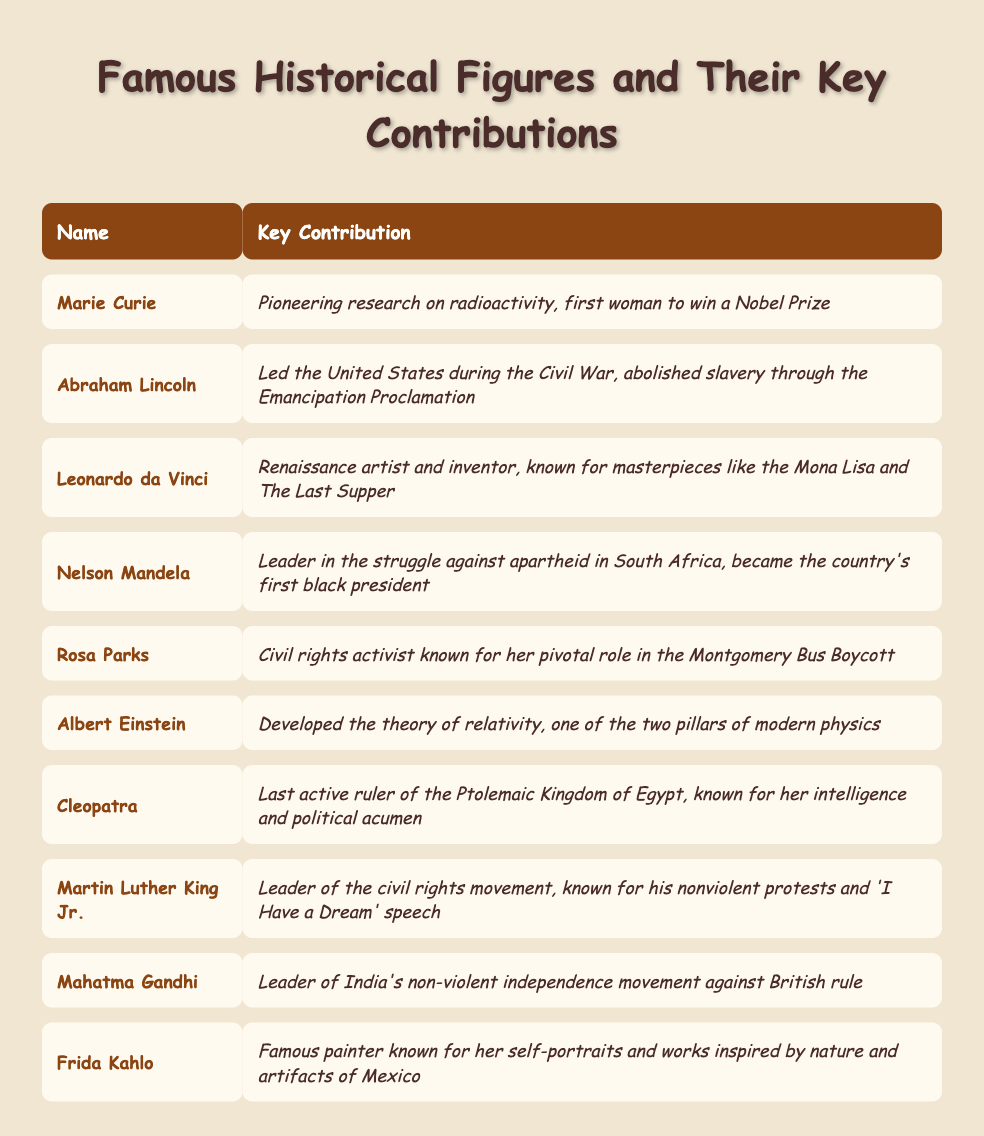What was Marie Curie's key contribution? Marie Curie's key contribution, as stated in the table, is pioneering research on radioactivity and being the first woman to win a Nobel Prize.
Answer: Pioneering research on radioactivity, first woman to win a Nobel Prize Who was the leader of the civil rights movement? The table indicates that Martin Luther King Jr. was the leader of the civil rights movement.
Answer: Martin Luther King Jr Which historical figure is known for the 'I Have a Dream' speech? Referring to the table, it shows that Martin Luther King Jr. is known for his 'I Have a Dream' speech.
Answer: Martin Luther King Jr Did Cleopatra rule Egypt? According to the table, it is true that Cleopatra was the last active ruler of the Ptolemaic Kingdom of Egypt.
Answer: Yes How many contributions focused on civil rights? From the table, both Martin Luther King Jr. and Rosa Parks focused on civil rights, making a total of 2 contributions in that area.
Answer: 2 Who contributed to the theory of relativity? The table specifies that Albert Einstein developed the theory of relativity.
Answer: Albert Einstein Which figure is associated with the Montgomery Bus Boycott? The table lists Rosa Parks as the civil rights activist who played a pivotal role in the Montgomery Bus Boycott.
Answer: Rosa Parks What is the contribution of Leonardo da Vinci? Leonardo da Vinci's contribution, as outlined in the table, includes being a Renaissance artist and inventor known for masterpieces like the Mona Lisa.
Answer: Renaissance artist and inventor, known for masterpieces like the Mona Lisa How does Nelson Mandela's contribution compare to Abraham Lincoln's in terms of leadership? Both Nelson Mandela and Abraham Lincoln were leaders during significant periods of conflict (apartheid in South Africa and the Civil War in the U.S.), but Mandela became the first black president of South Africa, while Lincoln is known for abolishing slavery through the Emancipation Proclamation.
Answer: Both were leaders during conflicts; Mandela became the first black president Which person is noted for their artwork inspired by nature? The table states that Frida Kahlo is known for her self-portraits and works inspired by nature and artifacts of Mexico.
Answer: Frida Kahlo 